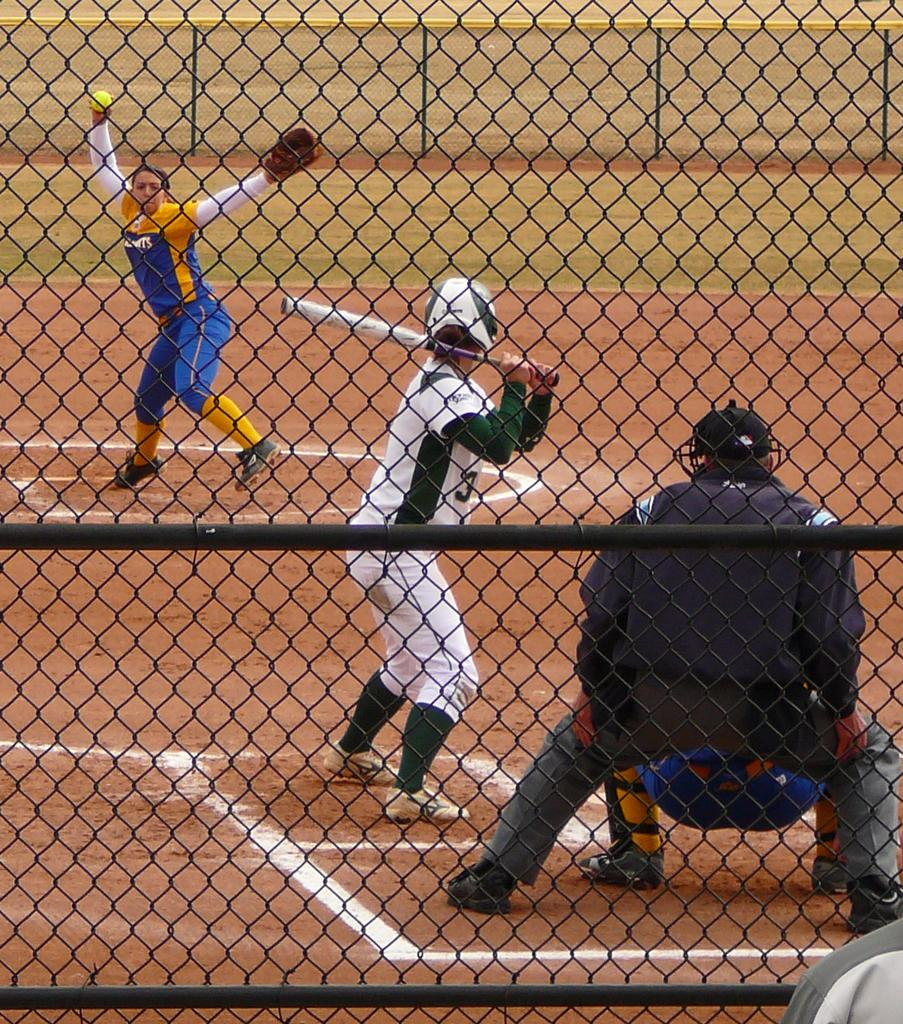What is the person in the image holding? The person is holding a bat. What is the position of the bat in the image? The bat is on the ground. Can you describe the second person in the image? The second person is holding a ball. What type of nail is being used in the war depicted in the image? There is no war or nail present in the image; it features two people holding a bat and a ball. 